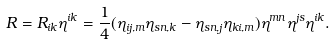Convert formula to latex. <formula><loc_0><loc_0><loc_500><loc_500>R = R _ { i k } \eta ^ { i k } = \frac { 1 } { 4 } ( \eta _ { i j , m } \eta _ { s n , k } - \eta _ { s n , j } \eta _ { k i , m } ) \eta ^ { m n } \eta ^ { j s } \eta ^ { i k } .</formula> 